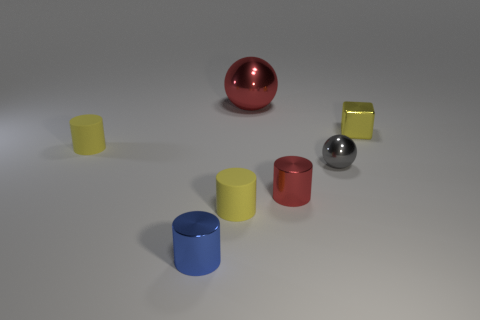Subtract 2 cylinders. How many cylinders are left? 2 Subtract all blue cylinders. How many cylinders are left? 3 Subtract all gray balls. How many yellow cylinders are left? 2 Subtract all small red cylinders. How many cylinders are left? 3 Add 1 small balls. How many objects exist? 8 Subtract all brown cylinders. Subtract all purple cubes. How many cylinders are left? 4 Subtract all spheres. How many objects are left? 5 Subtract all gray rubber spheres. Subtract all small red shiny cylinders. How many objects are left? 6 Add 2 red metal cylinders. How many red metal cylinders are left? 3 Add 6 small blue shiny balls. How many small blue shiny balls exist? 6 